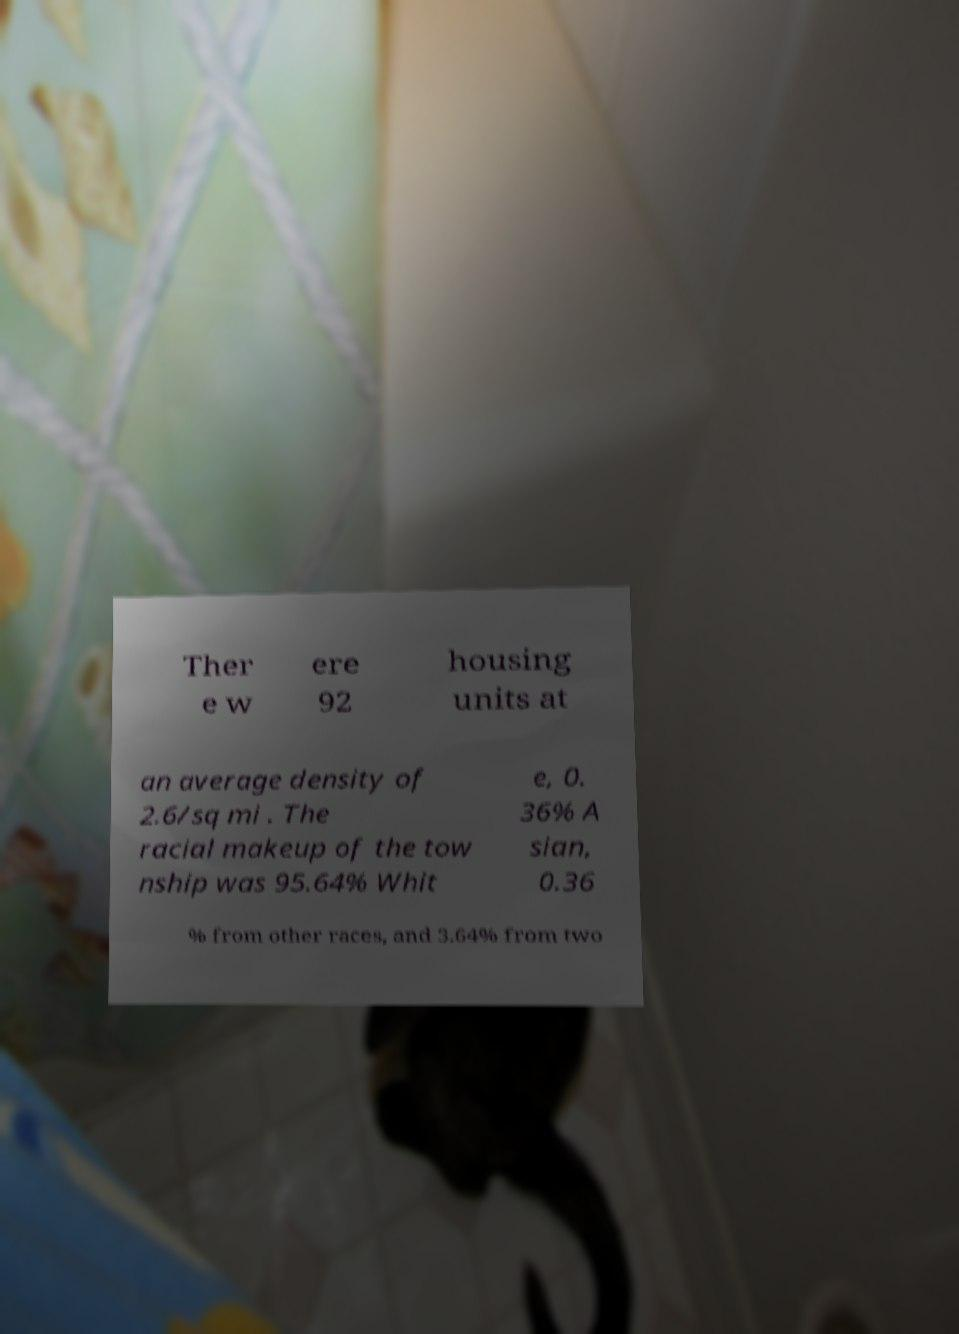What messages or text are displayed in this image? I need them in a readable, typed format. Ther e w ere 92 housing units at an average density of 2.6/sq mi . The racial makeup of the tow nship was 95.64% Whit e, 0. 36% A sian, 0.36 % from other races, and 3.64% from two 